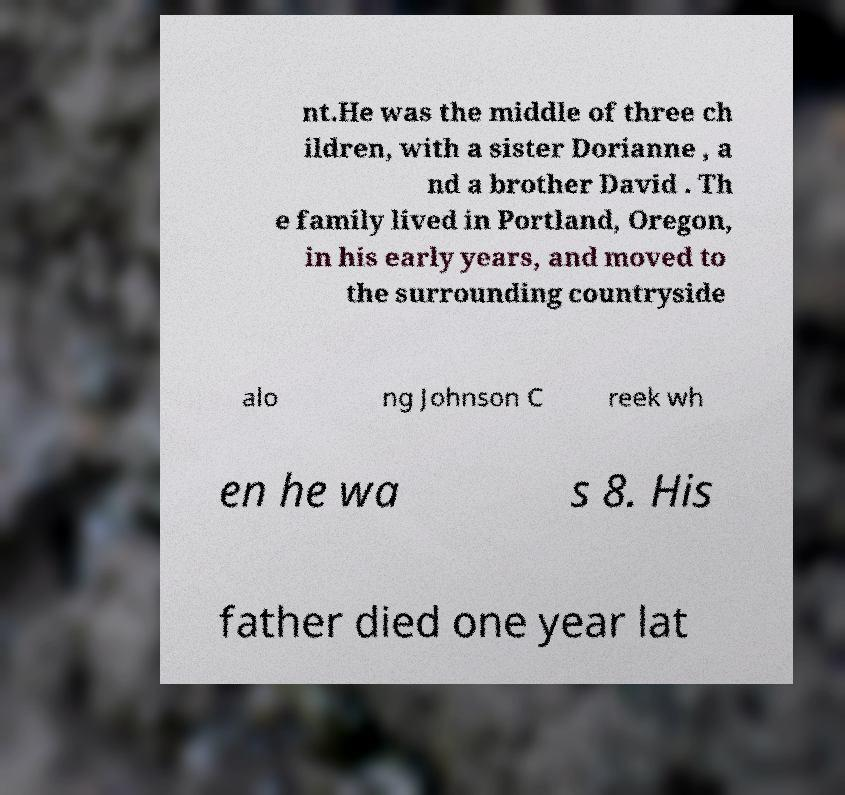Can you read and provide the text displayed in the image?This photo seems to have some interesting text. Can you extract and type it out for me? nt.He was the middle of three ch ildren, with a sister Dorianne , a nd a brother David . Th e family lived in Portland, Oregon, in his early years, and moved to the surrounding countryside alo ng Johnson C reek wh en he wa s 8. His father died one year lat 